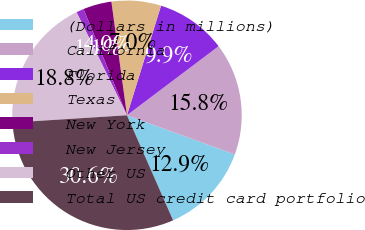<chart> <loc_0><loc_0><loc_500><loc_500><pie_chart><fcel>(Dollars in millions)<fcel>California<fcel>Florida<fcel>Texas<fcel>New York<fcel>New Jersey<fcel>Other US<fcel>Total US credit card portfolio<nl><fcel>12.87%<fcel>15.82%<fcel>9.92%<fcel>6.97%<fcel>4.01%<fcel>1.06%<fcel>18.77%<fcel>30.58%<nl></chart> 